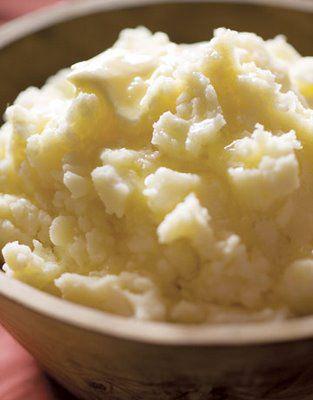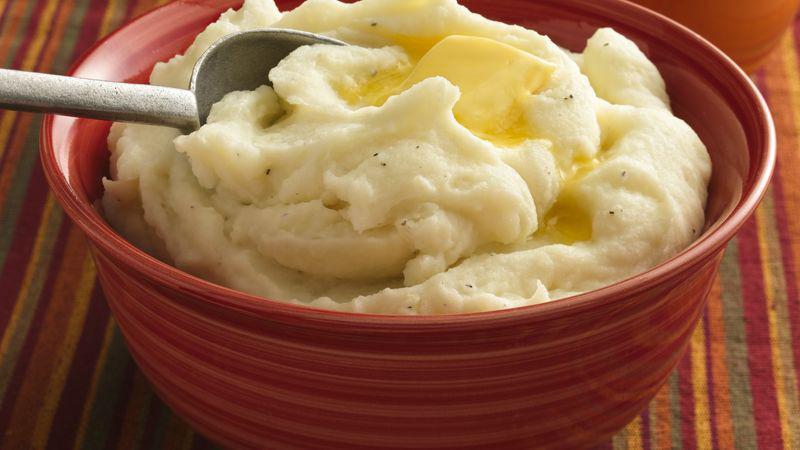The first image is the image on the left, the second image is the image on the right. Examine the images to the left and right. Is the description "the image on the left has potatoes in a square bowl" accurate? Answer yes or no. No. 